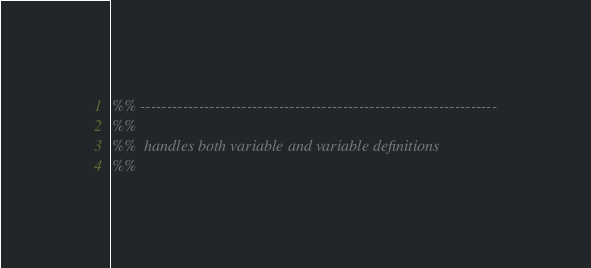<code> <loc_0><loc_0><loc_500><loc_500><_Erlang_>%% -------------------------------------------------------------------
%%
%%  handles both variable and variable definitions
%%</code> 